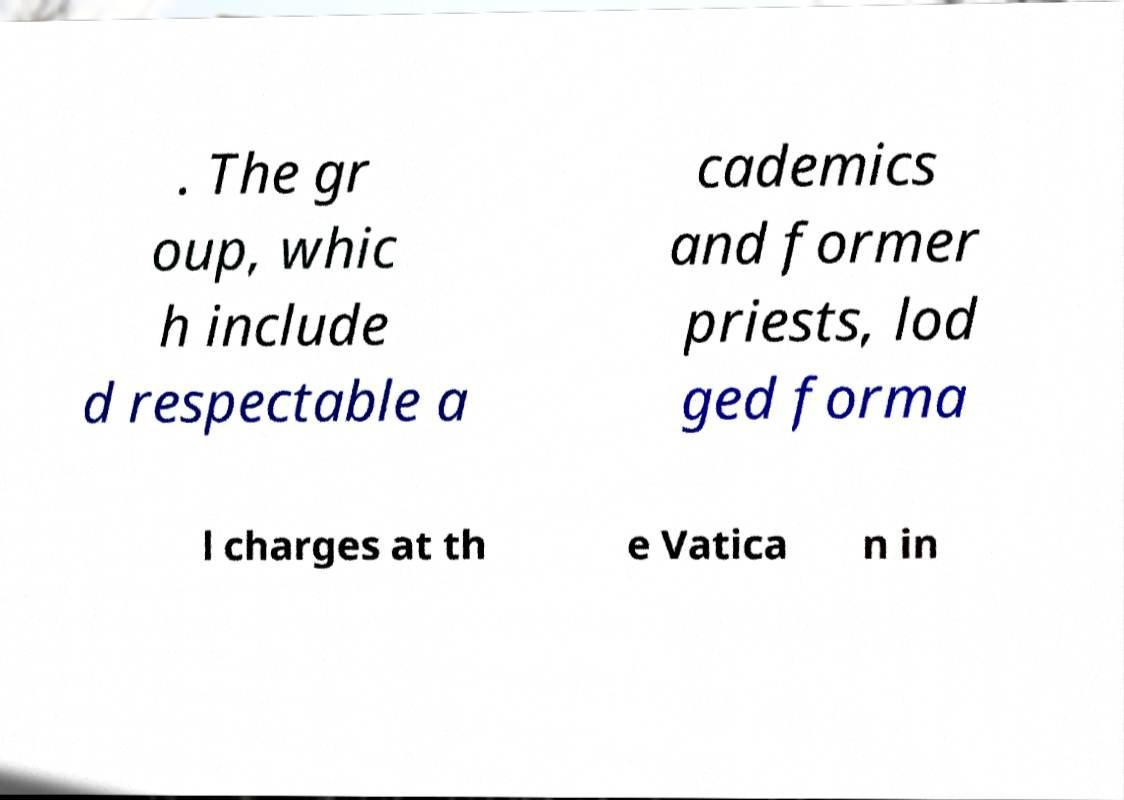There's text embedded in this image that I need extracted. Can you transcribe it verbatim? . The gr oup, whic h include d respectable a cademics and former priests, lod ged forma l charges at th e Vatica n in 